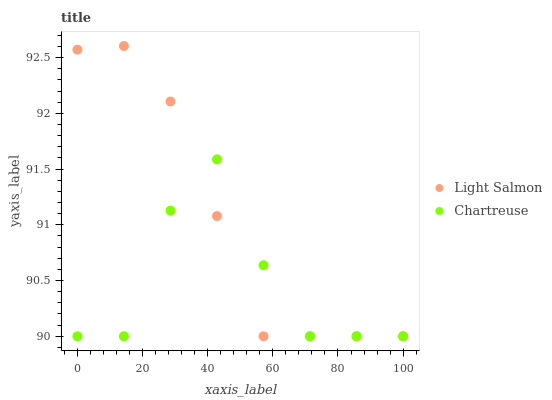Does Chartreuse have the minimum area under the curve?
Answer yes or no. Yes. Does Light Salmon have the maximum area under the curve?
Answer yes or no. Yes. Does Chartreuse have the maximum area under the curve?
Answer yes or no. No. Is Light Salmon the smoothest?
Answer yes or no. Yes. Is Chartreuse the roughest?
Answer yes or no. Yes. Is Chartreuse the smoothest?
Answer yes or no. No. Does Light Salmon have the lowest value?
Answer yes or no. Yes. Does Light Salmon have the highest value?
Answer yes or no. Yes. Does Chartreuse have the highest value?
Answer yes or no. No. Does Light Salmon intersect Chartreuse?
Answer yes or no. Yes. Is Light Salmon less than Chartreuse?
Answer yes or no. No. Is Light Salmon greater than Chartreuse?
Answer yes or no. No. 